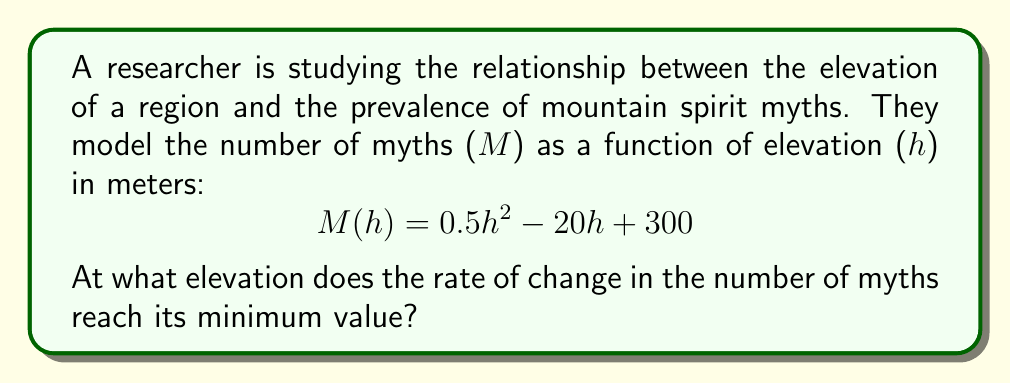Show me your answer to this math problem. To find the elevation where the rate of change in the number of myths reaches its minimum value, we need to follow these steps:

1) First, we need to find the rate of change of M with respect to h. This is the first derivative of M(h):

   $\frac{dM}{dh} = M'(h) = (0.5h^2 - 20h + 300)'$
   $M'(h) = h - 20$

2) The question asks for the minimum value of this rate of change. To find this, we need to find where the derivative of M'(h) equals zero. This is the second derivative of M(h):

   $\frac{d^2M}{dh^2} = M''(h) = (h - 20)' = 1$

3) Since M''(h) is a constant (1) and is always positive, this means that M'(h) is always increasing. Therefore, the minimum value of M'(h) occurs at the lowest possible value of h in the domain.

4) Given that elevation cannot be negative, the lowest possible value for h is 0.

5) Therefore, the elevation at which the rate of change in the number of myths reaches its minimum value is 0 meters.

This approach aligns with the researcher's expertise in regional legends, as it helps identify the point where the relationship between elevation and myth prevalence begins to change most rapidly.
Answer: 0 meters 